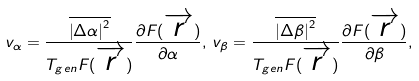Convert formula to latex. <formula><loc_0><loc_0><loc_500><loc_500>v _ { \alpha } = \frac { \overline { \left | \Delta \alpha \right | ^ { 2 } } } { { T _ { g e n } F ( \overrightarrow { r } ) } } \frac { \partial F ( \overrightarrow { r } ) } { \partial \alpha } , \, v _ { \beta } = \frac { \overline { \left | \Delta \beta \right | ^ { 2 } } } { { T _ { g e n } F ( \overrightarrow { r } ) } } \frac { \partial F ( \overrightarrow { r } ) } { \partial \beta } ,</formula> 